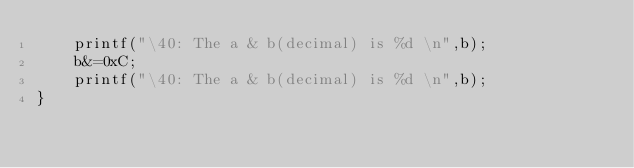<code> <loc_0><loc_0><loc_500><loc_500><_C++_>    printf("\40: The a & b(decimal) is %d \n",b);
    b&=0xC;
    printf("\40: The a & b(decimal) is %d \n",b);
}
</code> 